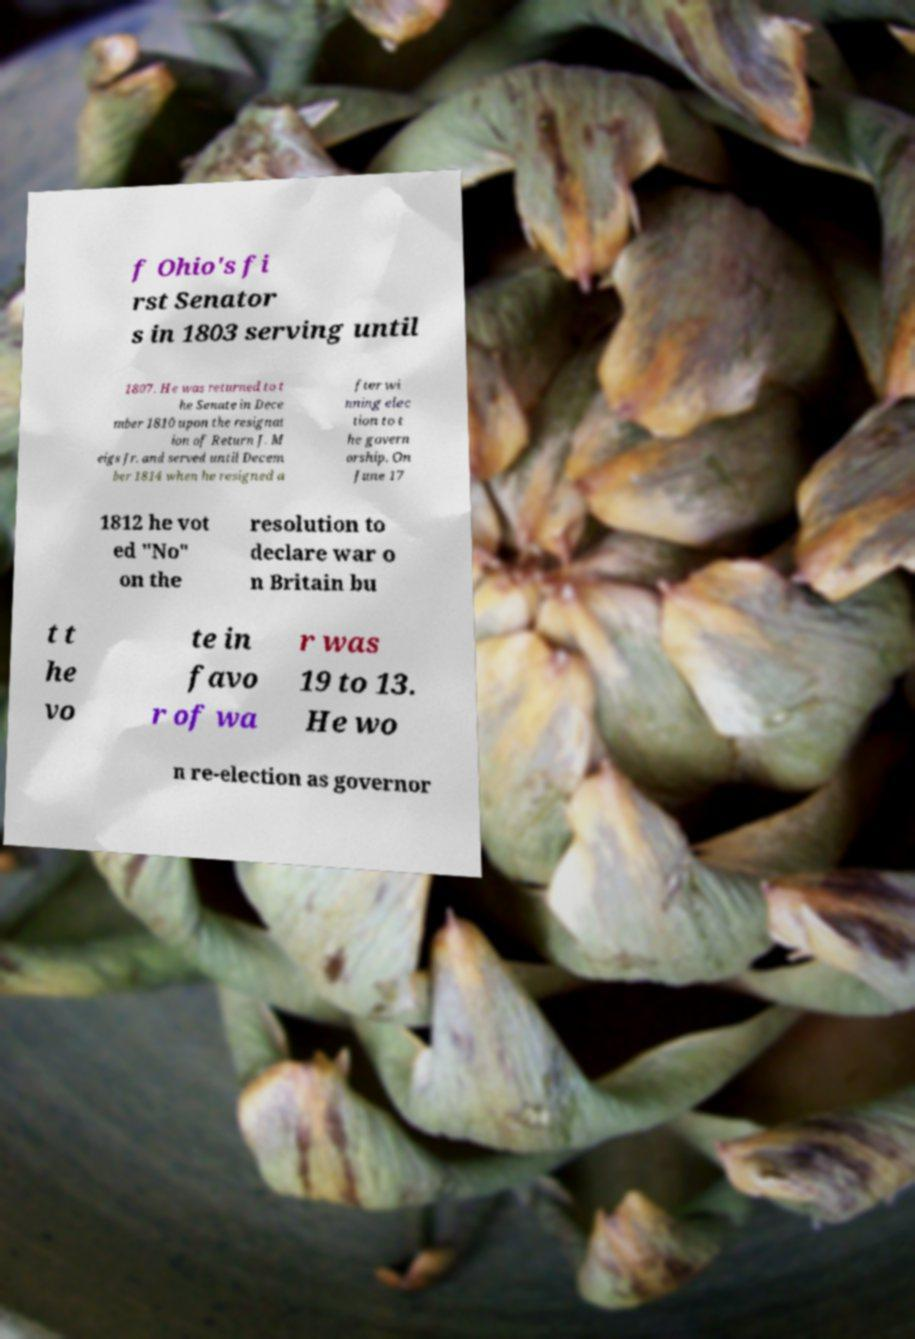I need the written content from this picture converted into text. Can you do that? f Ohio's fi rst Senator s in 1803 serving until 1807. He was returned to t he Senate in Dece mber 1810 upon the resignat ion of Return J. M eigs Jr. and served until Decem ber 1814 when he resigned a fter wi nning elec tion to t he govern orship. On June 17 1812 he vot ed "No" on the resolution to declare war o n Britain bu t t he vo te in favo r of wa r was 19 to 13. He wo n re-election as governor 